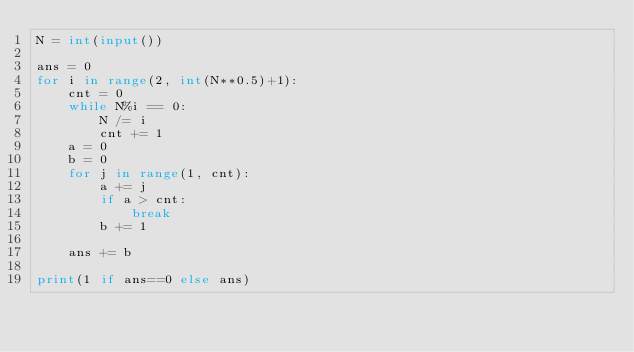<code> <loc_0><loc_0><loc_500><loc_500><_Python_>N = int(input())

ans = 0
for i in range(2, int(N**0.5)+1):
    cnt = 0
    while N%i == 0:
        N /= i
        cnt += 1
    a = 0
    b = 0
    for j in range(1, cnt):
        a += j
        if a > cnt:
            break
        b += 1
        
    ans += b

print(1 if ans==0 else ans)</code> 